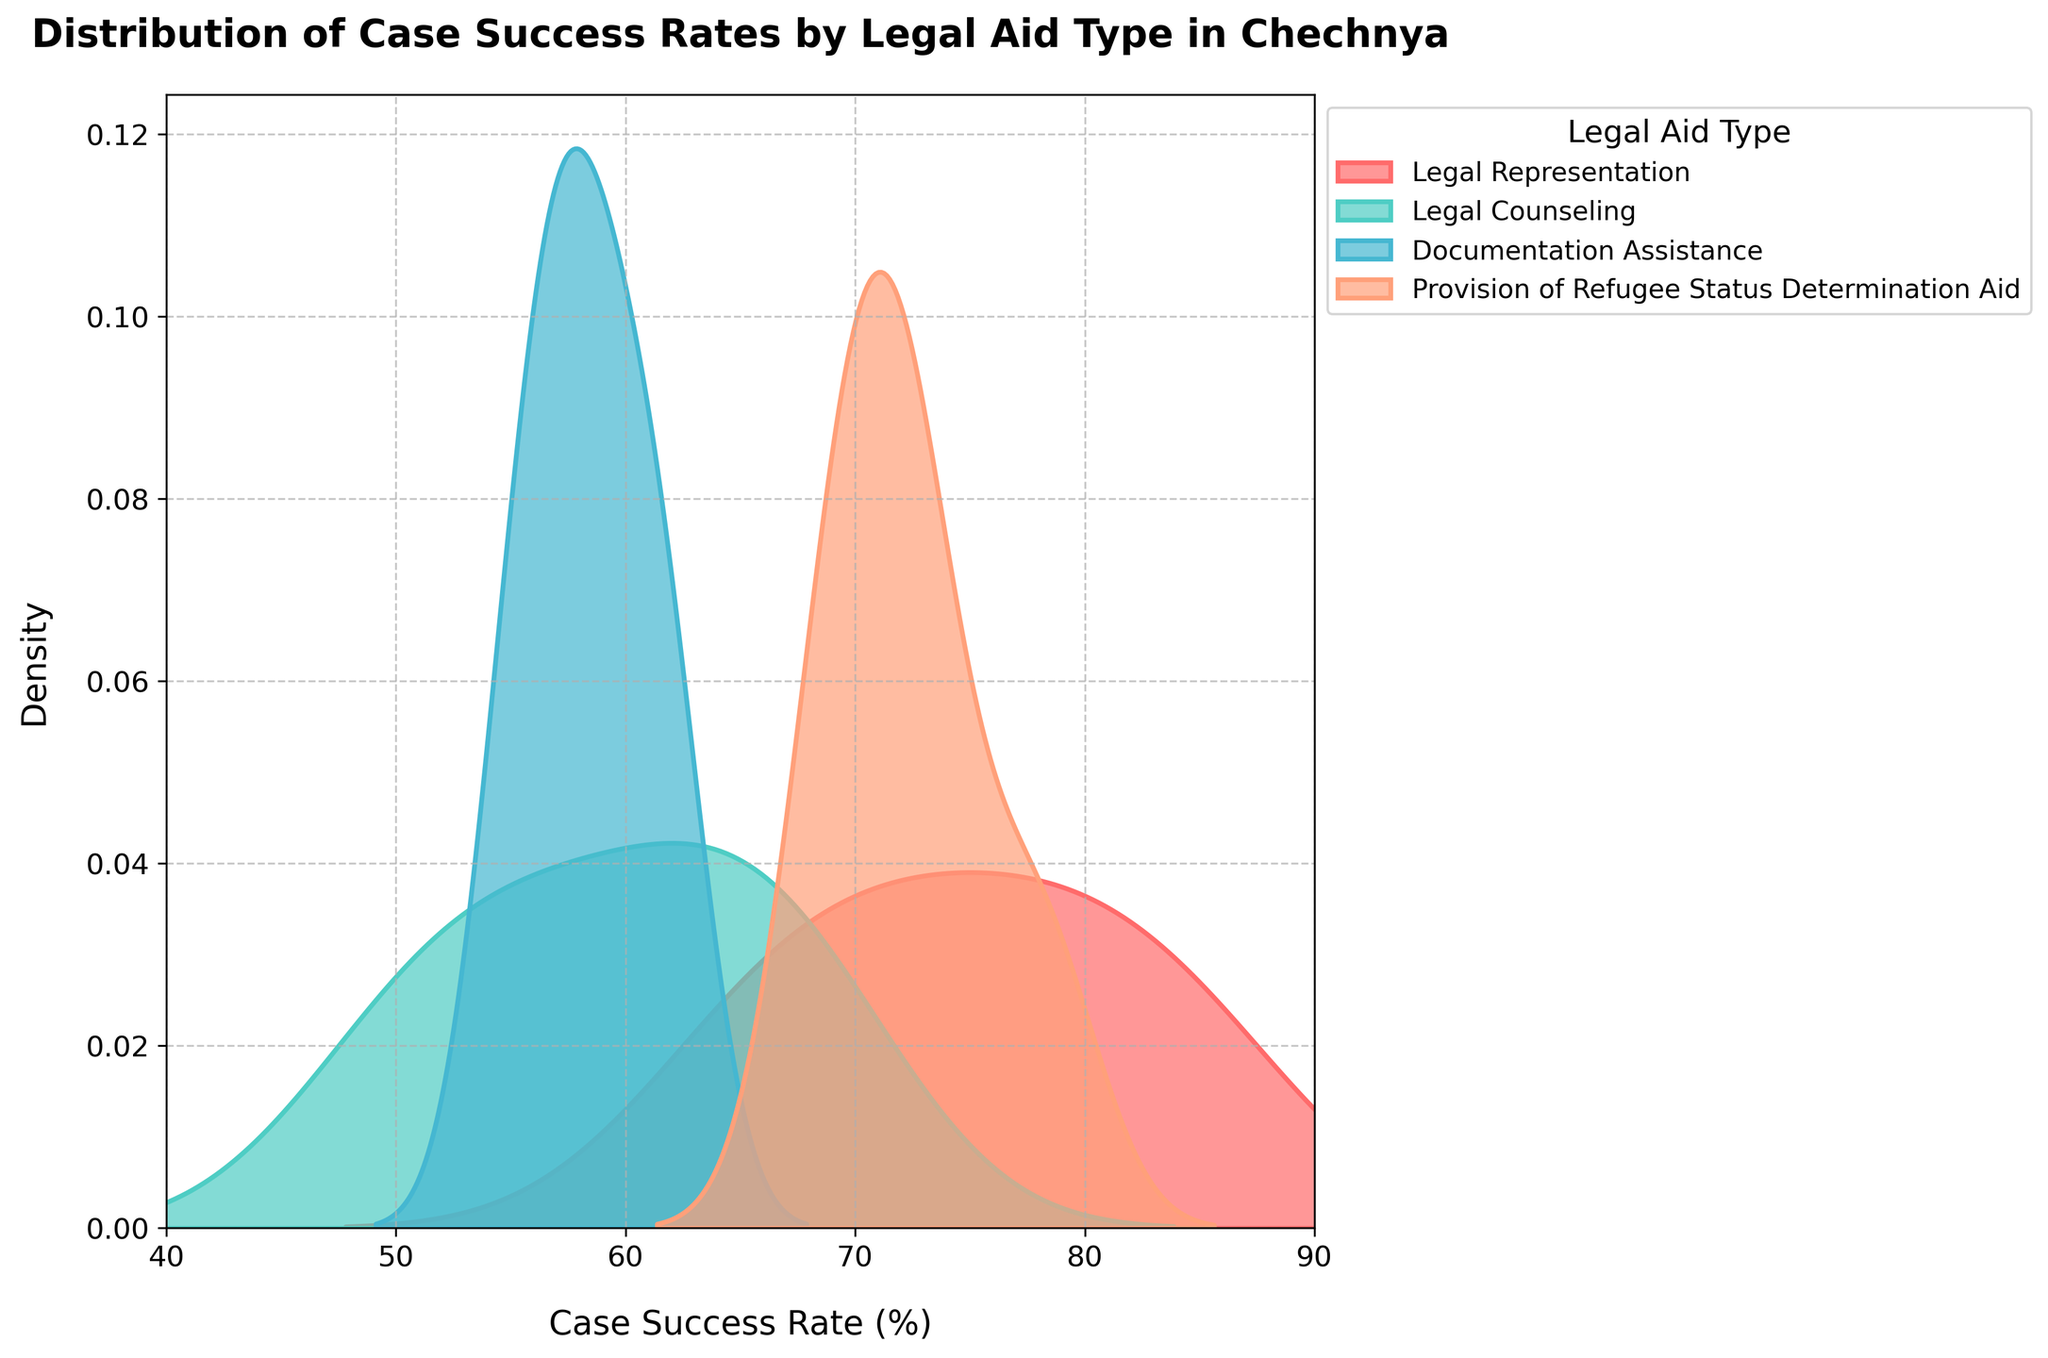What's the title of the figure? The title of a figure is typically located at the top and is a textual description of what the figure represents. In this case, the title is "Distribution of Case Success Rates by Legal Aid Type in Chechnya".
Answer: Distribution of Case Success Rates by Legal Aid Type in Chechnya What is the x-axis labeled? The x-axis label is usually the first horizontal label below the plot. Here, it indicates what the horizontal values represent, which is "Case Success Rate (%)".
Answer: Case Success Rate (%) What legal aid type shows the broadest distribution in case success rates? By observing the spread and width of the density curves, the broadest distribution can be identified. "Legal Representation" shows the widest spread indicating the most varied success rates.
Answer: Legal Representation Which legal aid type has the highest peak in the distribution? The highest peak or the tallest density curve indicates the most frequent success rate for a legal aid type. "Provision of Refugee Status Determination Aid" exhibits the highest peak.
Answer: Provision of Refugee Status Determination Aid What is the approximate range of case success rates for "Legal Representation"? By referring to the x-axis values where the curve for "Legal Representation" starts and ends, we can determine the range. It starts around 65% and ends near 85%.
Answer: 65% to 85% Among the types of legal aid, which has the lowest density at 60% success rate? Density is indicated by the height of the curve at a given x-axis value. By checking the curves at 60%, "Provision of Refugee Status Determination Aid" has the lowest density.
Answer: Provision of Refugee Status Determination Aid What type of legal aid shows success rates predominantly below 60%? By observing where curves are highest below 60%, "Documentation Assistance" shows most of its distribution in this range.
Answer: Documentation Assistance Which two legal aid types have overlapping distributions around the 65-70% success rate? Overlaps can be noticed where curves intersect around a specific x-axis range. "Legal Representation" and "Legal Counseling" overlap significantly in this range.
Answer: Legal Representation and Legal Counseling What is the range of case success rates for "Provision of Refugee Status Determination Aid"? Identifying the start and end points of the distribution curve for "Provision of Refugee Status Determination Aid", it ranges from about 69% to 78%.
Answer: 69% to 78% What legal aid type has the most consistent (least varied) success rates? The narrowest distribution shows the most consistent success rates. "Provision of Refugee Status Determination Aid" has the most narrow distribution, indicating consistent success rates.
Answer: Provision of Refugee Status Determination Aid 